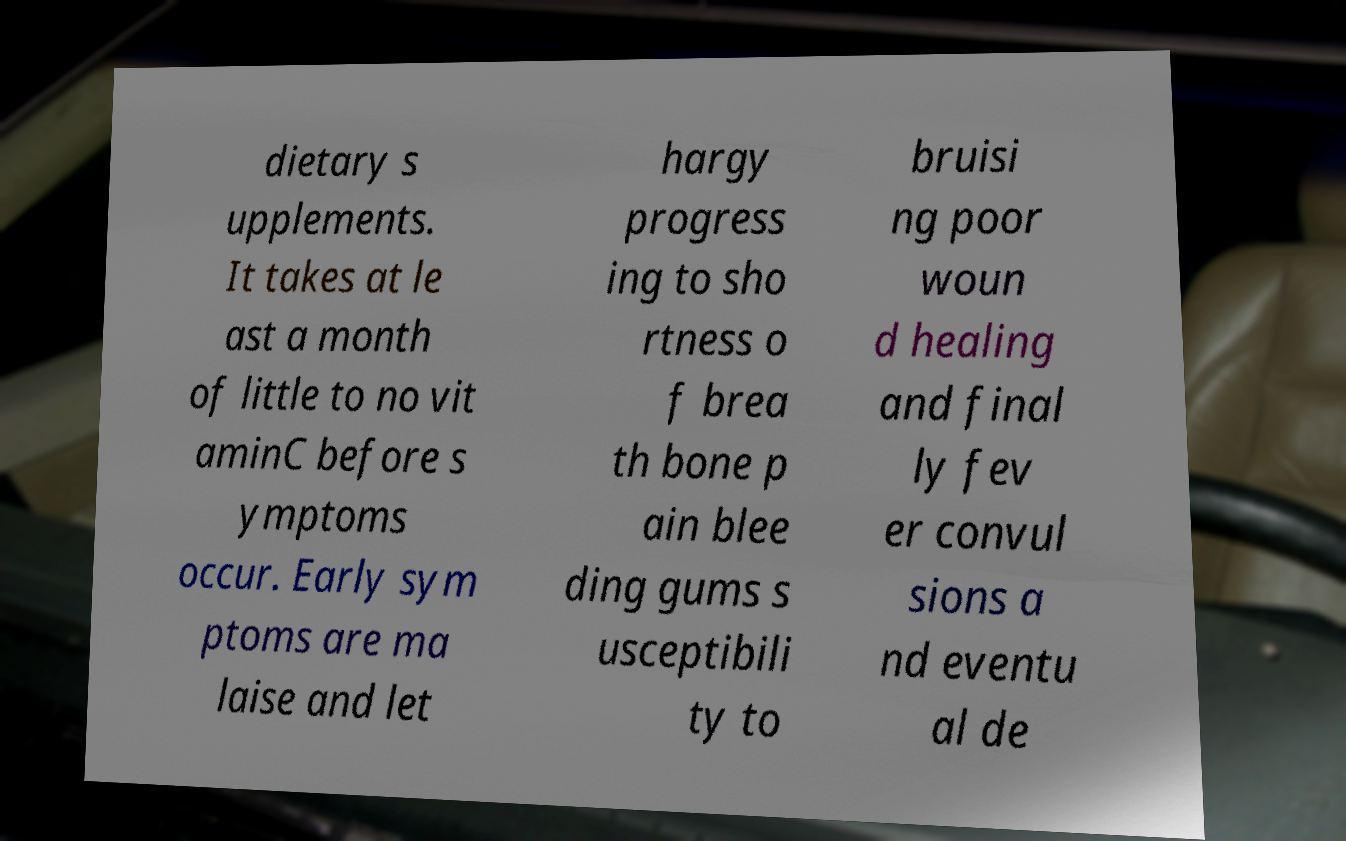What messages or text are displayed in this image? I need them in a readable, typed format. dietary s upplements. It takes at le ast a month of little to no vit aminC before s ymptoms occur. Early sym ptoms are ma laise and let hargy progress ing to sho rtness o f brea th bone p ain blee ding gums s usceptibili ty to bruisi ng poor woun d healing and final ly fev er convul sions a nd eventu al de 